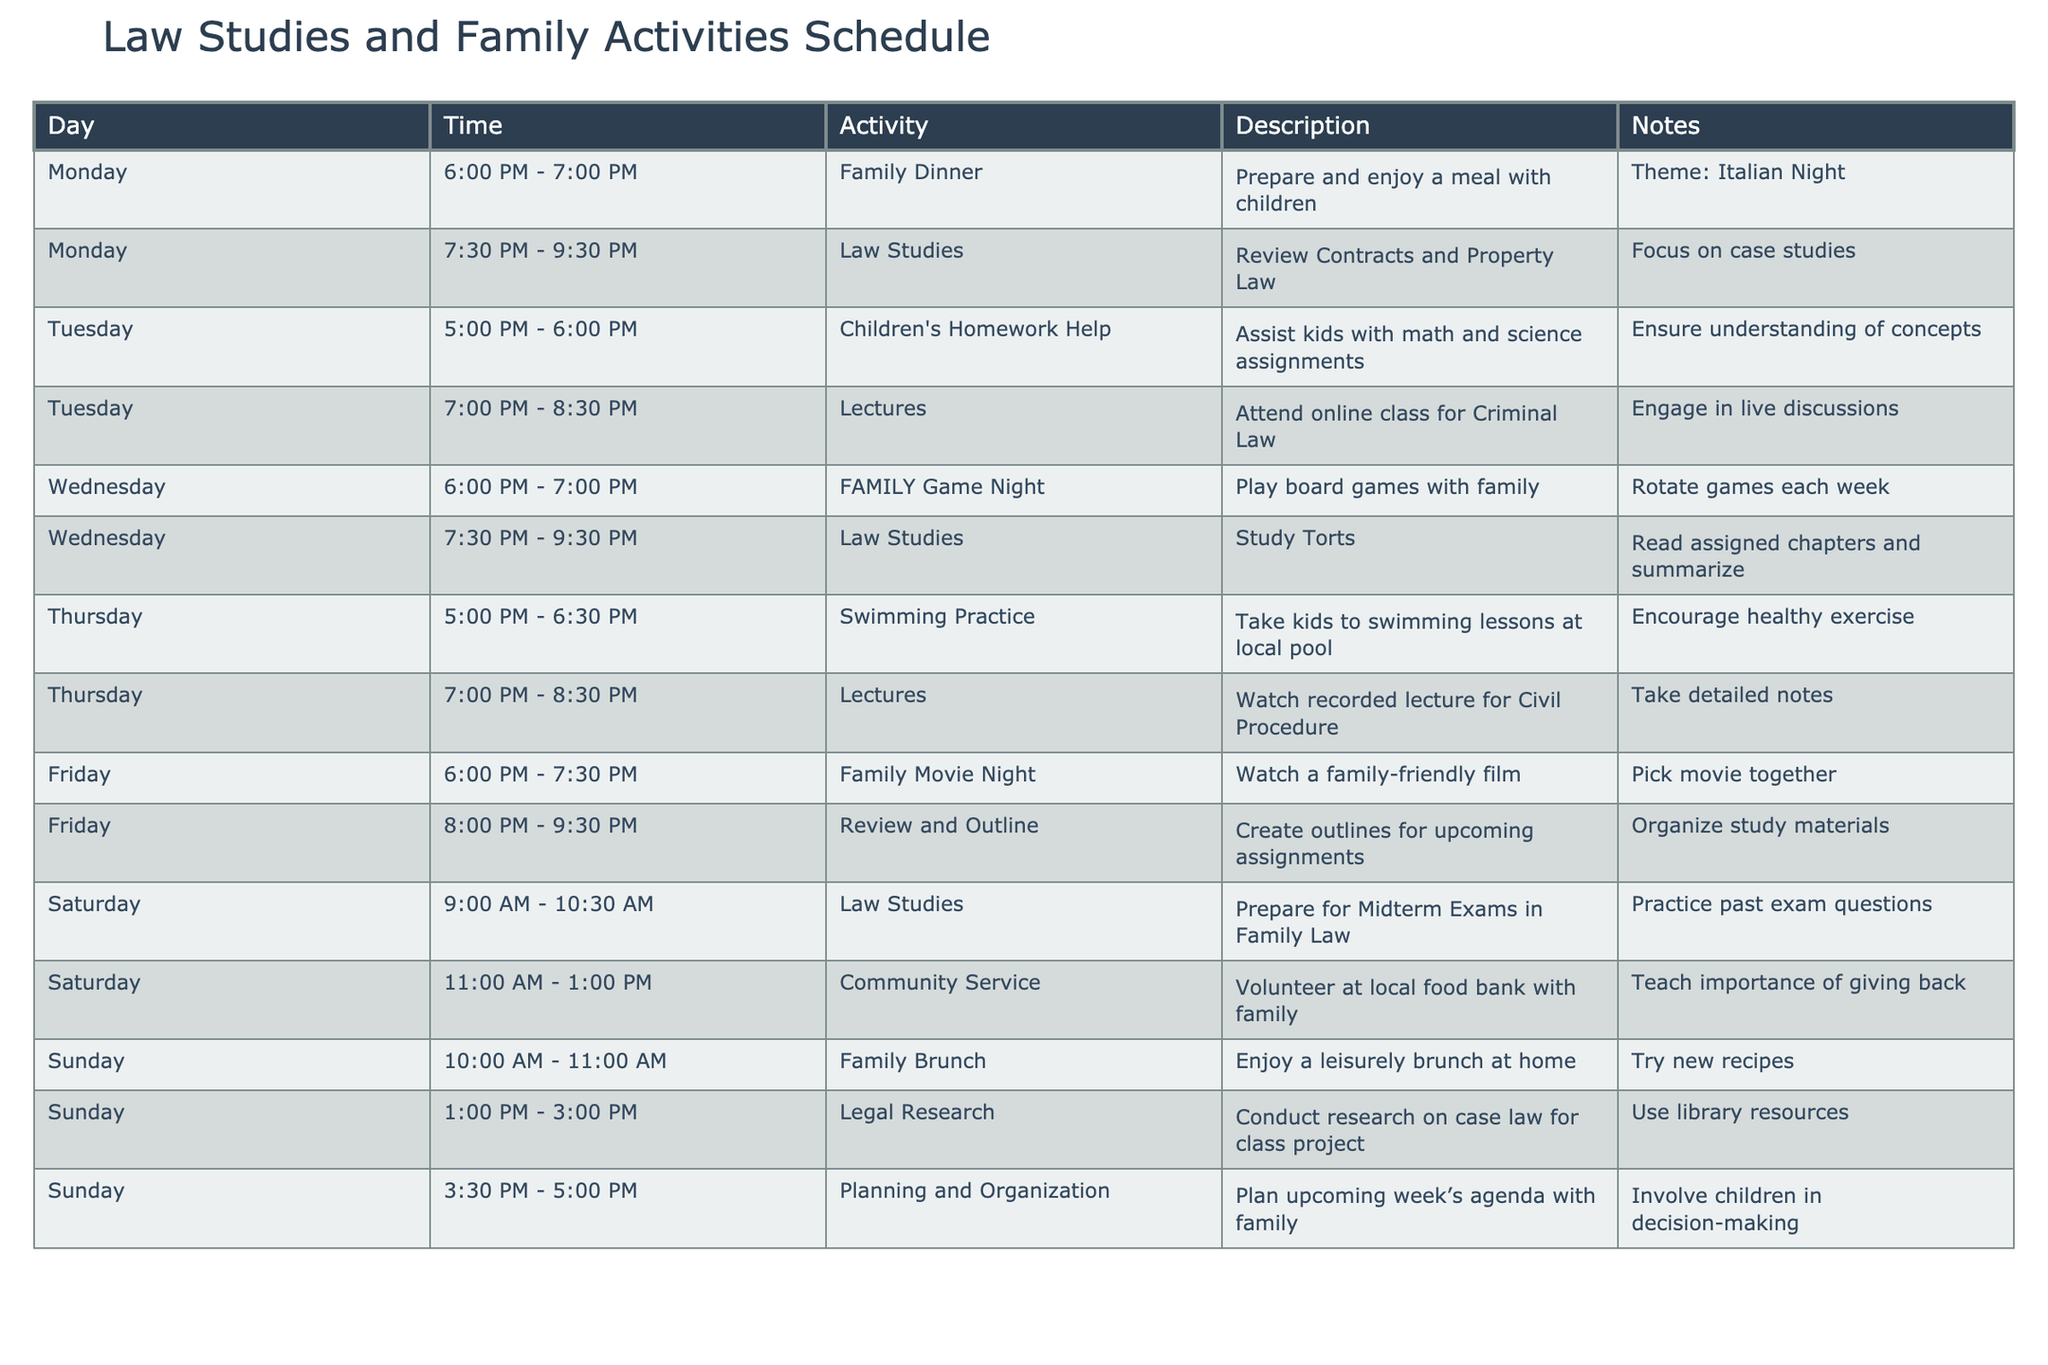What time is the Family Dinner scheduled? The table shows that Family Dinner is scheduled on Monday from 6:00 PM to 7:00 PM.
Answer: 6:00 PM - 7:00 PM How many hours are allocated for Law Studies in a week? The table indicates Law Studies on Monday (2 hours), Wednesday (2 hours), Friday (1.5 hours), and Saturday (1.5 hours), totaling 7 hours.
Answer: 7 hours Is there a Family Movie Night on Friday? The table lists Family Movie Night under Friday activities, confirming its occurrence.
Answer: Yes What activity occurs for the longest duration on Sunday? The table shows that Family Brunch lasts from 10:00 AM to 11:00 AM (1 hour), and Legal Research spans from 1:00 PM to 3:00 PM (2 hours), making Legal Research the longest.
Answer: Legal Research Which day has both family and law-related activities? Monday has Family Dinner followed by Law Studies, which combines family and law activities on the same day.
Answer: Monday How many total family activities are planned throughout the week? Family activities are on Monday, Wednesday, Thursday, Friday, Saturday, and Sunday, totaling 6 family activities.
Answer: 6 activities What is the scheduled time for Children's Homework Help? According to the table, Children's Homework Help is planned for Tuesday from 5:00 PM to 6:00 PM.
Answer: 5:00 PM - 6:00 PM Are there any swimming practices scheduled for the weekend? The table shows swimming practice on Thursday but no activities related to swimming on the weekend.
Answer: No Which law subject is being reviewed on Wednesday? The table states that Torts is the law subject being studied on Wednesday from 7:30 PM to 9:30 PM.
Answer: Torts What is the timeframe for the Community Service activity? The table indicates that Community Service is scheduled for Saturday from 11:00 AM to 1:00 PM.
Answer: 11:00 AM - 1:00 PM What is the pattern of evening activities on weekdays? Weekday evening activities consist of Family Dinner, Law Studies, Lectures, and Family Game Night, showing a structured approach for family and education.
Answer: Structured approach 